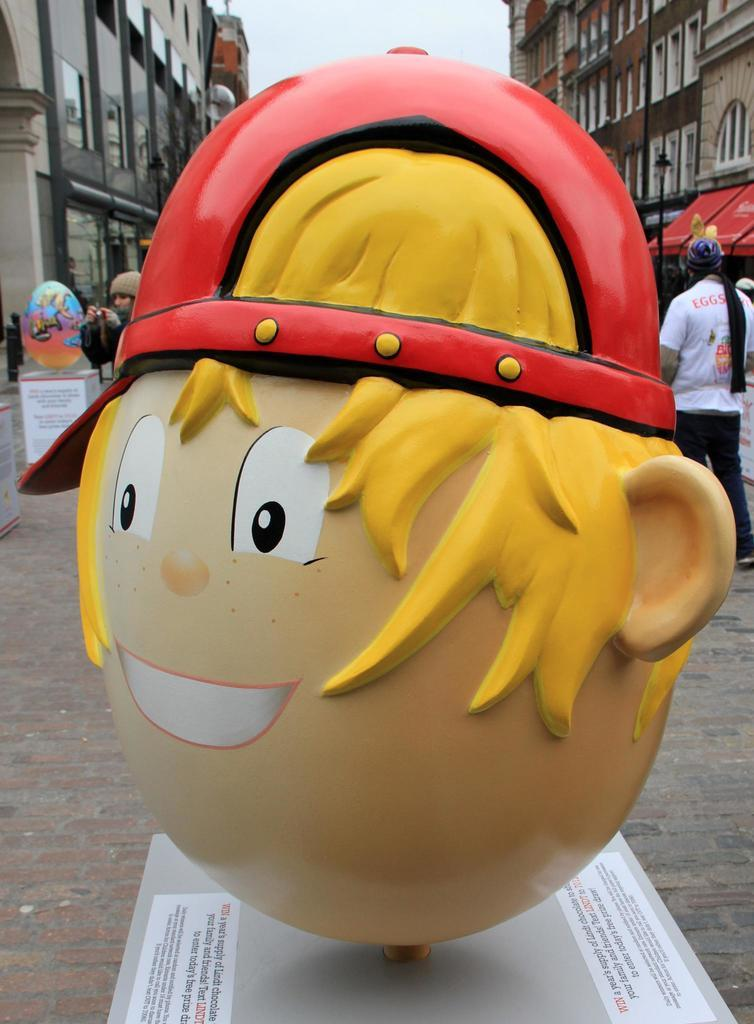What is on the platform in the image? There is a mascot on a platform in the image. What can be seen on the platform besides the mascot? Something is written on the platform. What can be seen in the distance behind the platform? There are buildings and the sky visible in the background. Are there any people present in the image? Yes, there are people in the background. What type of leather material is being used by the mascot in the image? There is no leather material present in the image, as it features a mascot on a platform with people and buildings in the background. 